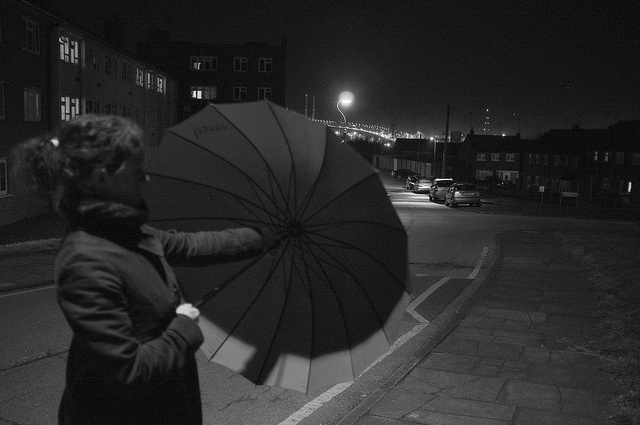Describe the objects in this image and their specific colors. I can see umbrella in black, gray, and lightgray tones, people in black, darkgray, and lightgray tones, car in black, gray, darkgray, and lightgray tones, car in black, gray, darkgray, and white tones, and car in black, gray, and lightgray tones in this image. 